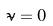<formula> <loc_0><loc_0><loc_500><loc_500>\tilde { \nu } = 0</formula> 